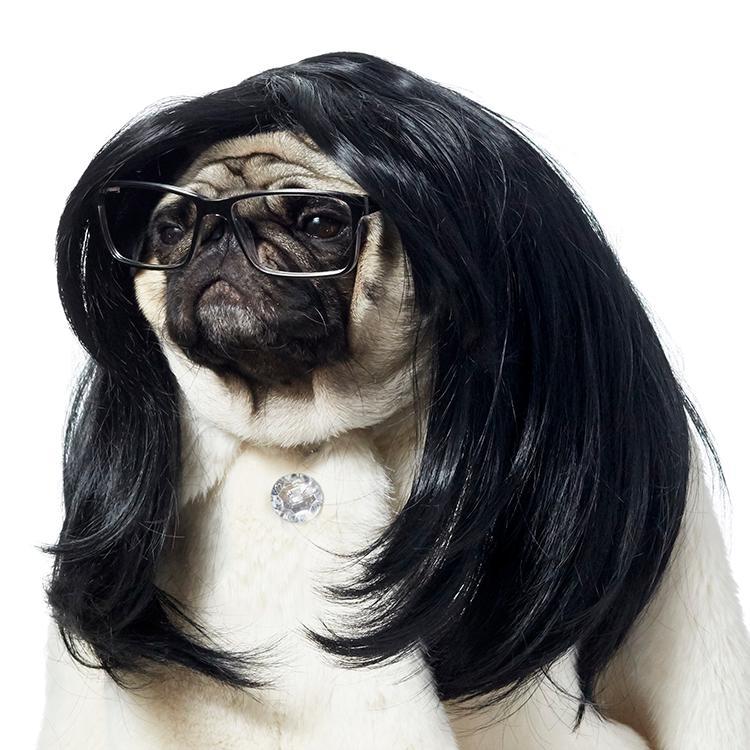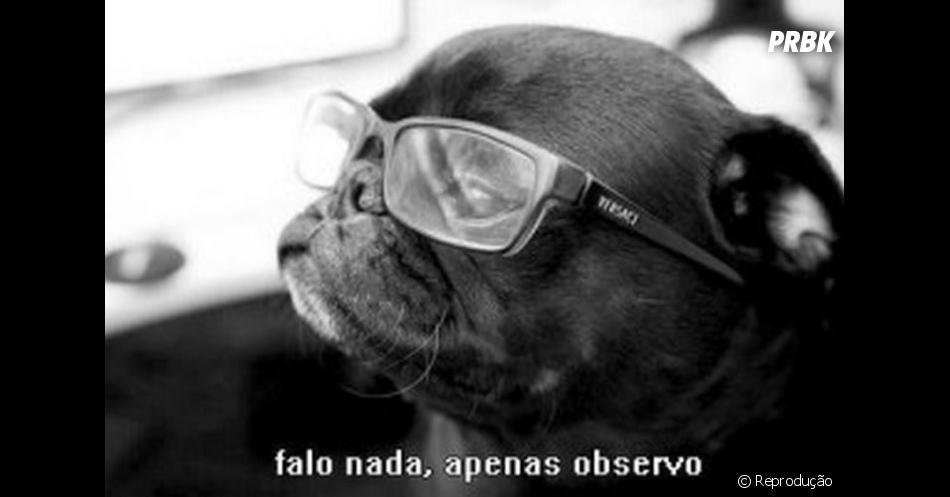The first image is the image on the left, the second image is the image on the right. Assess this claim about the two images: "The pug on the right is wearing glasses with round frames.". Correct or not? Answer yes or no. No. The first image is the image on the left, the second image is the image on the right. Examine the images to the left and right. Is the description "The pug in the right image faces the camera head-on and wears glasses with round lenses." accurate? Answer yes or no. No. 